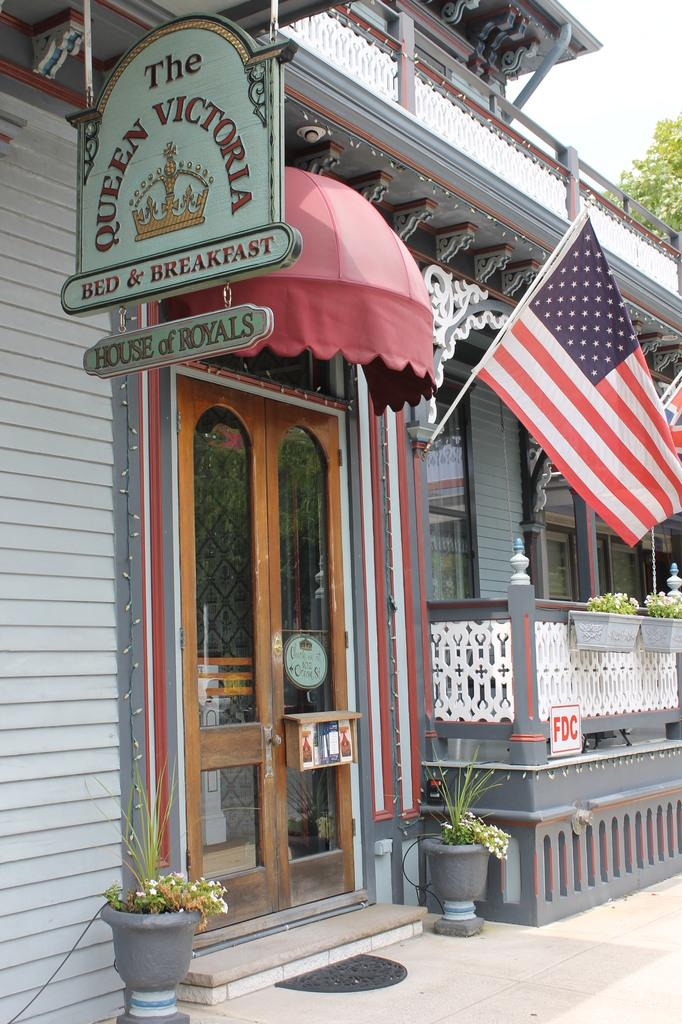Provide a one-sentence caption for the provided image. Queen Victoria Bed and breakfast  with red awning and american flag. 